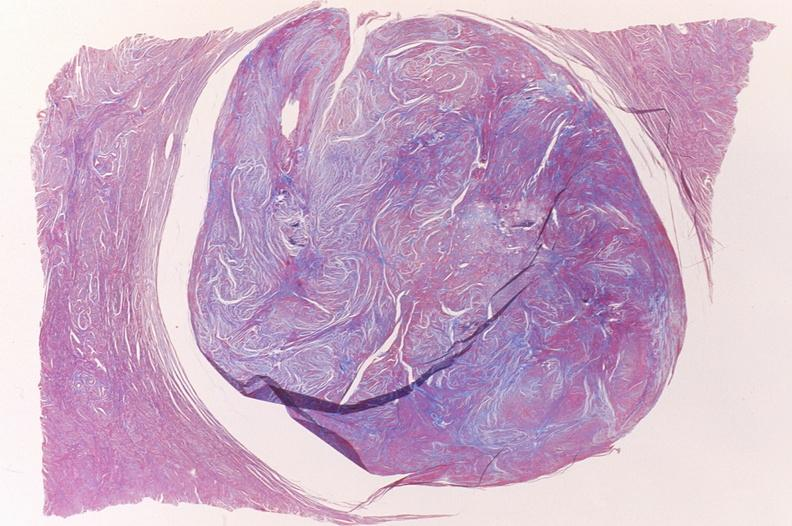what is present?
Answer the question using a single word or phrase. Female reproductive 